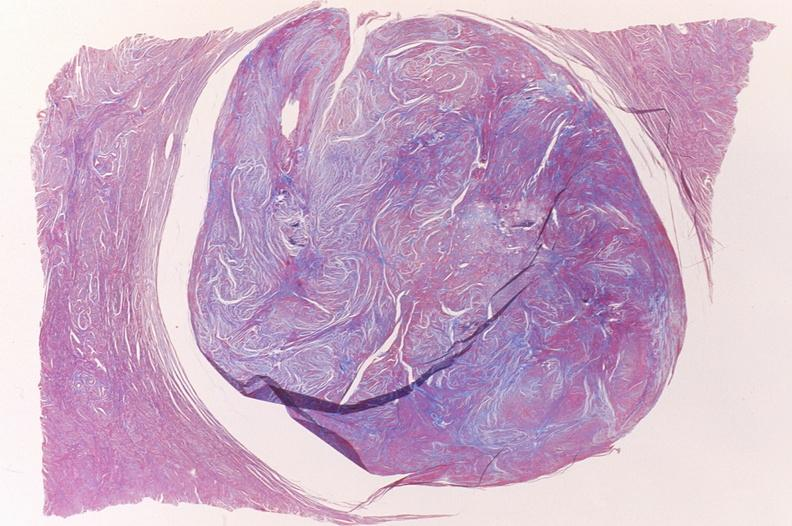what is present?
Answer the question using a single word or phrase. Female reproductive 